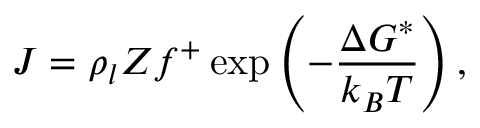Convert formula to latex. <formula><loc_0><loc_0><loc_500><loc_500>J = \rho _ { l } Z f ^ { + } \exp \left ( - \frac { \Delta G ^ { * } } { k _ { B } T } \right ) ,</formula> 